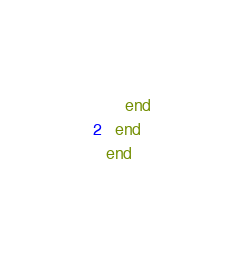<code> <loc_0><loc_0><loc_500><loc_500><_Ruby_>    end
  end
end
</code> 